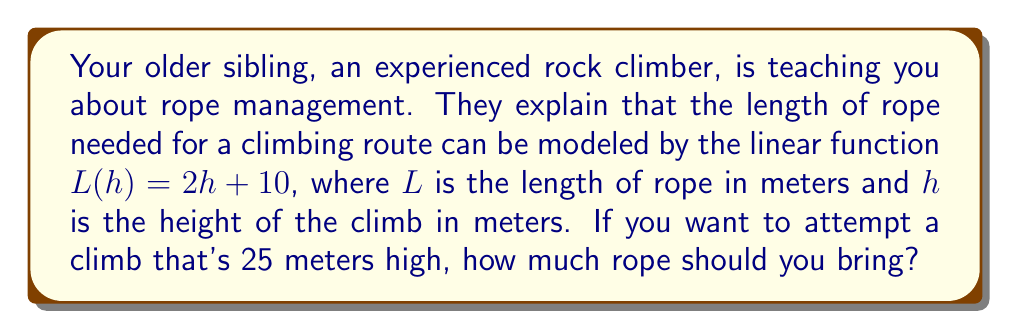Help me with this question. Let's approach this step-by-step:

1) We're given the linear function $L(h) = 2h + 10$, where:
   - $L$ is the length of rope needed in meters
   - $h$ is the height of the climb in meters

2) We need to find $L$ when $h = 25$ meters

3) To do this, we simply substitute $h = 25$ into the function:

   $L(25) = 2(25) + 10$

4) Now let's solve this:
   $L(25) = 50 + 10$
   $L(25) = 60$

5) Therefore, for a 25-meter climb, you need 60 meters of rope.

This makes sense because:
- You need rope for both ascending and descending (hence the factor of 2)
- You need some extra rope for safety and setting up (the +10 in the equation)
Answer: 60 meters 